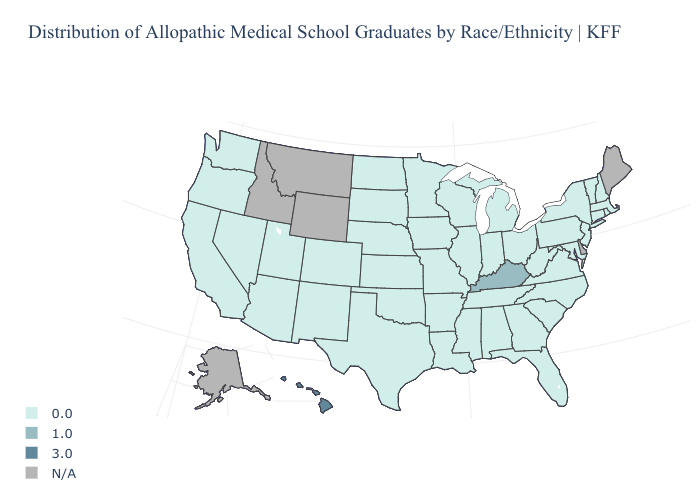Among the states that border Rhode Island , which have the highest value?
Answer briefly. Connecticut, Massachusetts. Name the states that have a value in the range 0.0?
Answer briefly. Alabama, Arizona, Arkansas, California, Colorado, Connecticut, Florida, Georgia, Illinois, Indiana, Iowa, Kansas, Louisiana, Maryland, Massachusetts, Michigan, Minnesota, Mississippi, Missouri, Nebraska, Nevada, New Hampshire, New Jersey, New Mexico, New York, North Carolina, North Dakota, Ohio, Oklahoma, Oregon, Pennsylvania, Rhode Island, South Carolina, South Dakota, Tennessee, Texas, Utah, Vermont, Virginia, Washington, West Virginia, Wisconsin. Does Hawaii have the highest value in the West?
Be succinct. Yes. What is the highest value in the MidWest ?
Be succinct. 0.0. Name the states that have a value in the range 3.0?
Quick response, please. Hawaii. Name the states that have a value in the range N/A?
Keep it brief. Alaska, Delaware, Idaho, Maine, Montana, Wyoming. What is the value of Florida?
Answer briefly. 0.0. Which states have the lowest value in the USA?
Give a very brief answer. Alabama, Arizona, Arkansas, California, Colorado, Connecticut, Florida, Georgia, Illinois, Indiana, Iowa, Kansas, Louisiana, Maryland, Massachusetts, Michigan, Minnesota, Mississippi, Missouri, Nebraska, Nevada, New Hampshire, New Jersey, New Mexico, New York, North Carolina, North Dakota, Ohio, Oklahoma, Oregon, Pennsylvania, Rhode Island, South Carolina, South Dakota, Tennessee, Texas, Utah, Vermont, Virginia, Washington, West Virginia, Wisconsin. What is the highest value in states that border Kansas?
Concise answer only. 0.0. Name the states that have a value in the range 0.0?
Concise answer only. Alabama, Arizona, Arkansas, California, Colorado, Connecticut, Florida, Georgia, Illinois, Indiana, Iowa, Kansas, Louisiana, Maryland, Massachusetts, Michigan, Minnesota, Mississippi, Missouri, Nebraska, Nevada, New Hampshire, New Jersey, New Mexico, New York, North Carolina, North Dakota, Ohio, Oklahoma, Oregon, Pennsylvania, Rhode Island, South Carolina, South Dakota, Tennessee, Texas, Utah, Vermont, Virginia, Washington, West Virginia, Wisconsin. Does the map have missing data?
Write a very short answer. Yes. Which states have the lowest value in the South?
Quick response, please. Alabama, Arkansas, Florida, Georgia, Louisiana, Maryland, Mississippi, North Carolina, Oklahoma, South Carolina, Tennessee, Texas, Virginia, West Virginia. Name the states that have a value in the range 0.0?
Give a very brief answer. Alabama, Arizona, Arkansas, California, Colorado, Connecticut, Florida, Georgia, Illinois, Indiana, Iowa, Kansas, Louisiana, Maryland, Massachusetts, Michigan, Minnesota, Mississippi, Missouri, Nebraska, Nevada, New Hampshire, New Jersey, New Mexico, New York, North Carolina, North Dakota, Ohio, Oklahoma, Oregon, Pennsylvania, Rhode Island, South Carolina, South Dakota, Tennessee, Texas, Utah, Vermont, Virginia, Washington, West Virginia, Wisconsin. Does Hawaii have the highest value in the USA?
Be succinct. Yes. Is the legend a continuous bar?
Give a very brief answer. No. 